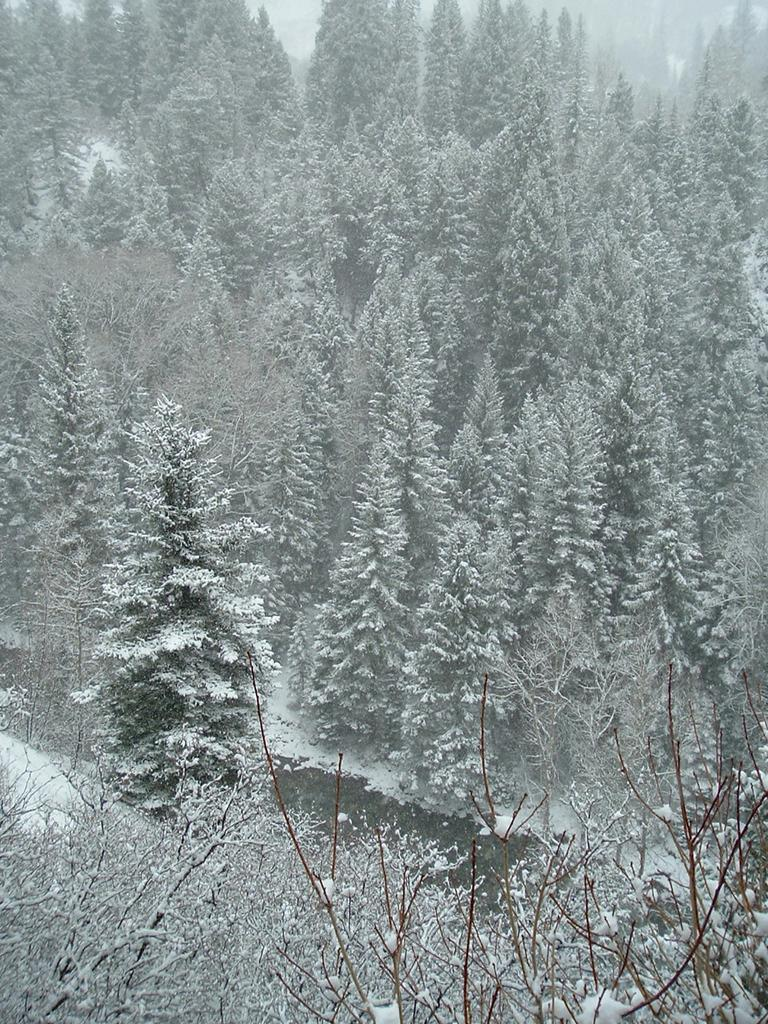What type of vegetation can be seen in the image? There are trees in the image. How are the trees in the image affected by the weather? The trees are fully covered with snow. What color crayon can be seen in the image? There are no crayons present in the image. What is the interest rate for the trees in the image? There is no reference to interest rates in the image, as it features trees covered in snow. 